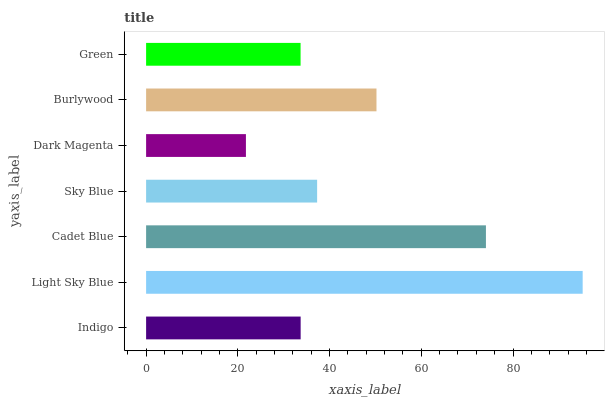Is Dark Magenta the minimum?
Answer yes or no. Yes. Is Light Sky Blue the maximum?
Answer yes or no. Yes. Is Cadet Blue the minimum?
Answer yes or no. No. Is Cadet Blue the maximum?
Answer yes or no. No. Is Light Sky Blue greater than Cadet Blue?
Answer yes or no. Yes. Is Cadet Blue less than Light Sky Blue?
Answer yes or no. Yes. Is Cadet Blue greater than Light Sky Blue?
Answer yes or no. No. Is Light Sky Blue less than Cadet Blue?
Answer yes or no. No. Is Sky Blue the high median?
Answer yes or no. Yes. Is Sky Blue the low median?
Answer yes or no. Yes. Is Indigo the high median?
Answer yes or no. No. Is Cadet Blue the low median?
Answer yes or no. No. 